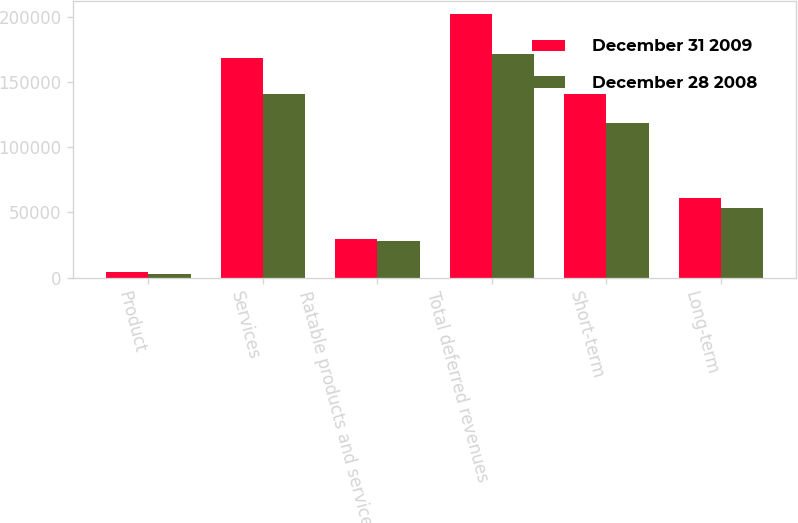Convert chart to OTSL. <chart><loc_0><loc_0><loc_500><loc_500><stacked_bar_chart><ecel><fcel>Product<fcel>Services<fcel>Ratable products and services<fcel>Total deferred revenues<fcel>Short-term<fcel>Long-term<nl><fcel>December 31 2009<fcel>4141<fcel>168314<fcel>29475<fcel>201930<fcel>140537<fcel>61393<nl><fcel>December 28 2008<fcel>2731<fcel>140407<fcel>28479<fcel>171617<fcel>118297<fcel>53320<nl></chart> 